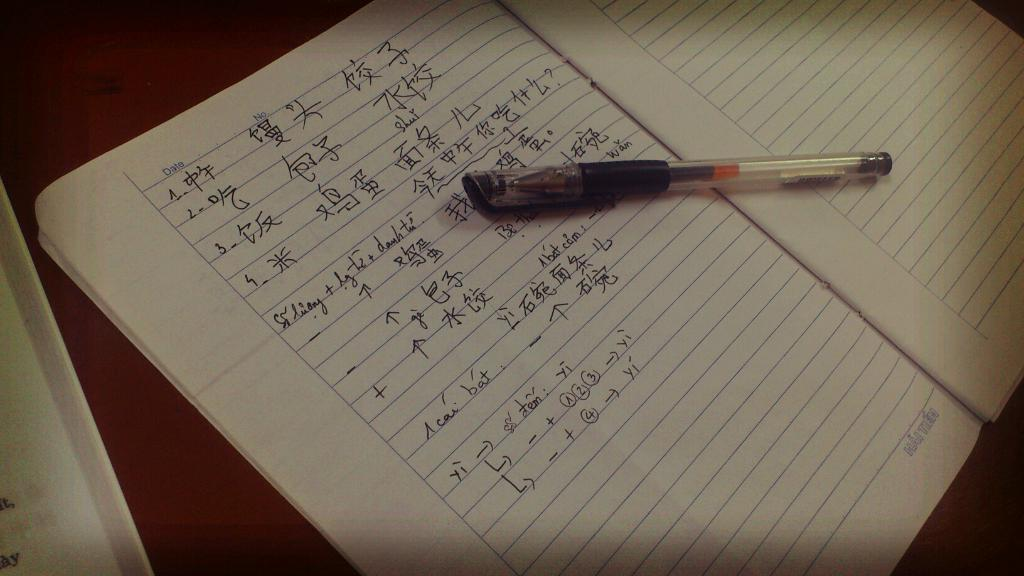What writing instrument is visible in the image? There is a pen in the image. What type of reading material is present in the image? There is a book and another book in the image. What is the color of the surface the objects are on? The surface the objects are on is brown in color. What type of popcorn is being served by the expert beast in the image? There is no popcorn, expert, or beast present in the image. 